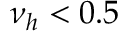<formula> <loc_0><loc_0><loc_500><loc_500>\nu _ { h } < 0 . 5</formula> 